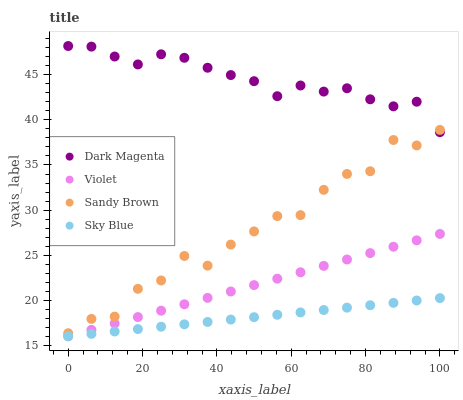Does Sky Blue have the minimum area under the curve?
Answer yes or no. Yes. Does Dark Magenta have the maximum area under the curve?
Answer yes or no. Yes. Does Sandy Brown have the minimum area under the curve?
Answer yes or no. No. Does Sandy Brown have the maximum area under the curve?
Answer yes or no. No. Is Sky Blue the smoothest?
Answer yes or no. Yes. Is Sandy Brown the roughest?
Answer yes or no. Yes. Is Dark Magenta the smoothest?
Answer yes or no. No. Is Dark Magenta the roughest?
Answer yes or no. No. Does Sky Blue have the lowest value?
Answer yes or no. Yes. Does Sandy Brown have the lowest value?
Answer yes or no. No. Does Dark Magenta have the highest value?
Answer yes or no. Yes. Does Sandy Brown have the highest value?
Answer yes or no. No. Is Sky Blue less than Dark Magenta?
Answer yes or no. Yes. Is Dark Magenta greater than Violet?
Answer yes or no. Yes. Does Violet intersect Sky Blue?
Answer yes or no. Yes. Is Violet less than Sky Blue?
Answer yes or no. No. Is Violet greater than Sky Blue?
Answer yes or no. No. Does Sky Blue intersect Dark Magenta?
Answer yes or no. No. 